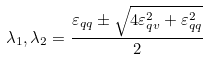Convert formula to latex. <formula><loc_0><loc_0><loc_500><loc_500>\lambda _ { 1 } , \lambda _ { 2 } = \frac { \varepsilon _ { q q } \pm \sqrt { 4 \varepsilon _ { q v } ^ { 2 } + \varepsilon _ { q q } ^ { 2 } } } { 2 }</formula> 